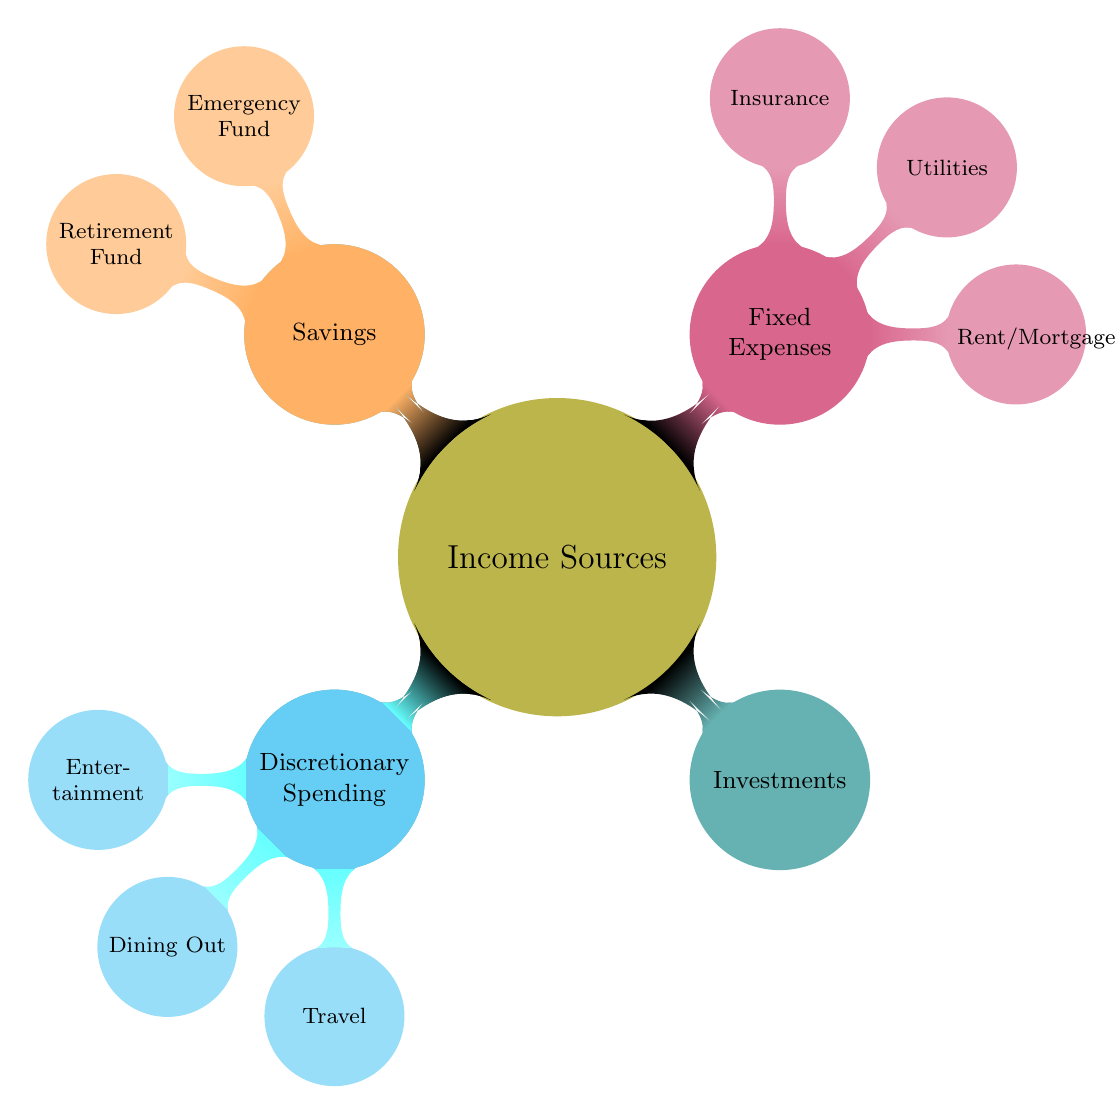What are the sources of income in this budget diagram? By examining the top-level node labeled "Income Sources," we can see that it branches into three sub-nodes: "Salary," "Freelance Work," and "Investments." These represent the various sources of income.
Answer: Salary, Freelance Work, Investments How many types of fixed expenses are listed? In the diagram, under the "Fixed Expenses" parent node, there are three child nodes: "Rent/Mortgage," "Utilities," and "Insurance." Therefore, the total count is three.
Answer: 3 What is the main category associated with "Emergency Fund"? "Emergency Fund" is a child node under the "Savings" parent node, indicating that it falls under the category of Savings.
Answer: Savings Which category does "Dining Out" belong to? The node "Dining Out" is a child of the "Discretionary Spending" node, showing that it is part of the discretionary expenses in the budget.
Answer: Discretionary Spending List two child nodes under "Savings." The "Savings" node has two sub-nodes: "Emergency Fund" and "Retirement Fund." These represent different types of savings in the budget.
Answer: Emergency Fund, Retirement Fund What is the relationship between "Utilities" and "Income Sources"? "Utilities" is a child node of the "Fixed Expenses" category, which is separate from "Income Sources." Therefore, they are in different branches of the diagram, indicating no direct relationship.
Answer: No direct relationship How many nodes are there in total in the entire diagram? The diagram contains one top-level node (Income Sources), three income source nodes, one fixed expenses node, three fixed expense nodes, one savings node, two savings nodes, one discretionary spending node, and three discretionary spending nodes. Counting all these together gives a total of 13 nodes.
Answer: 13 What colors are used for the different categories in the diagram? Each top-level category in the diagram is represented by a unique color: "Income Sources" (olive), "Fixed Expenses" (purple), "Savings" (orange), and "Discretionary Spending" (cyan).
Answer: Olive, Purple, Orange, Cyan What is the main purpose of the diagram? The main purpose of the diagram is to illustrate the structure of a monthly household budget, detailing various income sources, fixed expenses, savings options, and discretionary spending categories.
Answer: Illustrate a monthly household budget 